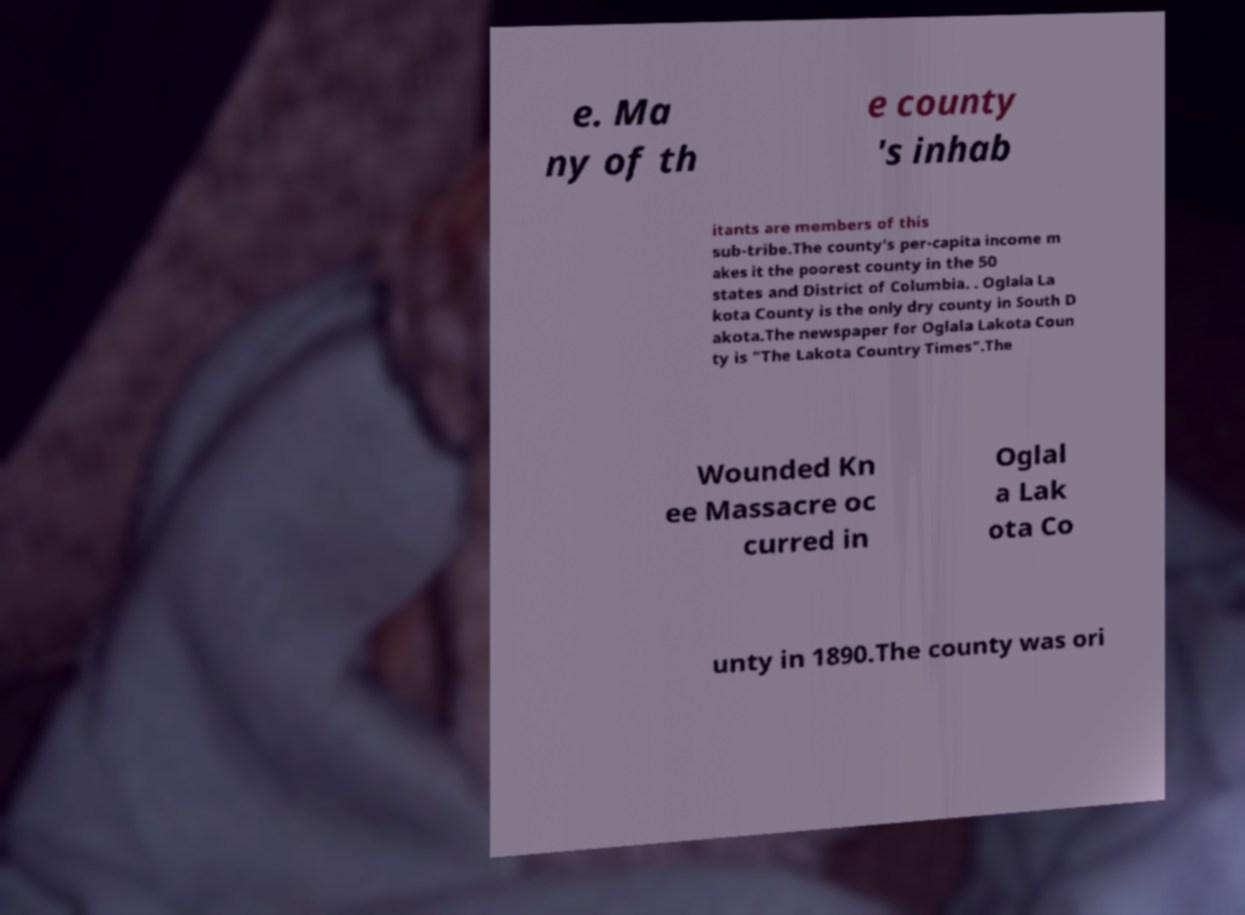Can you accurately transcribe the text from the provided image for me? e. Ma ny of th e county 's inhab itants are members of this sub-tribe.The county's per-capita income m akes it the poorest county in the 50 states and District of Columbia. . Oglala La kota County is the only dry county in South D akota.The newspaper for Oglala Lakota Coun ty is "The Lakota Country Times".The Wounded Kn ee Massacre oc curred in Oglal a Lak ota Co unty in 1890.The county was ori 